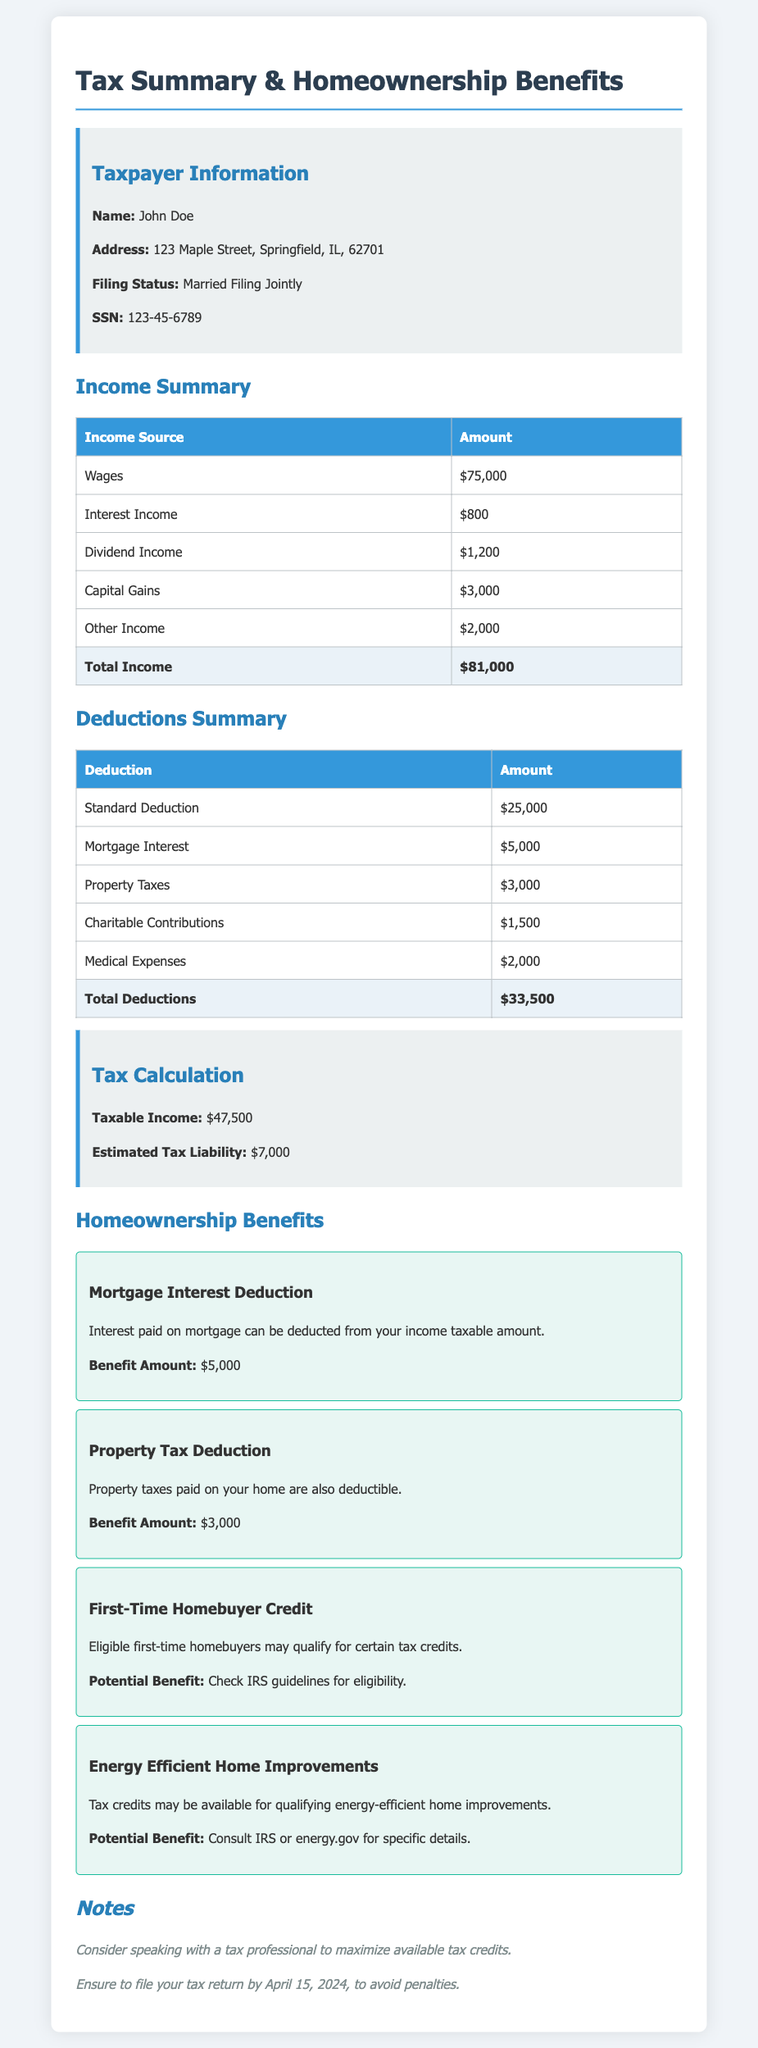What is the taxpayer's name? The taxpayer's name is provided in the document as "John Doe."
Answer: John Doe What is the total income reported? Total income is the sum of all income sources listed in the summary, which is $75,000 + $800 + $1,200 + $3,000 + $2,000 = $81,000.
Answer: $81,000 What is the amount for the standard deduction? The standard deduction amount is indicated in the deductions summary as $25,000.
Answer: $25,000 What is the taxable income? Taxable income is calculated as total income minus total deductions, which is $81,000 - $33,500 = $47,500.
Answer: $47,500 What is the estimated tax liability? The estimated tax liability is stated in the document as $7,000.
Answer: $7,000 What deductions are related to homeownership? Deductions related to homeownership mentioned are mortgage interest and property taxes, with amounts of $5,000 and $3,000 respectively.
Answer: Mortgage interest and property taxes What benefit amount can be claimed for mortgage interest deduction? The document specifies the benefit amount for mortgage interest deduction as $5,000.
Answer: $5,000 What potential benefit is available for energy-efficient home improvements? The potential benefit mentioned is a tax credit for qualifying energy-efficient home improvements.
Answer: Tax credit What is the deadline for filing the tax return? The document notes the filing deadline as April 15, 2024.
Answer: April 15, 2024 